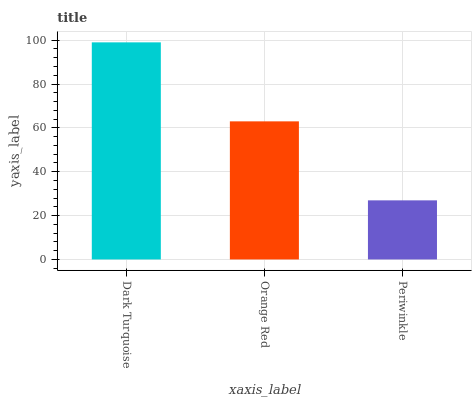Is Periwinkle the minimum?
Answer yes or no. Yes. Is Dark Turquoise the maximum?
Answer yes or no. Yes. Is Orange Red the minimum?
Answer yes or no. No. Is Orange Red the maximum?
Answer yes or no. No. Is Dark Turquoise greater than Orange Red?
Answer yes or no. Yes. Is Orange Red less than Dark Turquoise?
Answer yes or no. Yes. Is Orange Red greater than Dark Turquoise?
Answer yes or no. No. Is Dark Turquoise less than Orange Red?
Answer yes or no. No. Is Orange Red the high median?
Answer yes or no. Yes. Is Orange Red the low median?
Answer yes or no. Yes. Is Dark Turquoise the high median?
Answer yes or no. No. Is Periwinkle the low median?
Answer yes or no. No. 